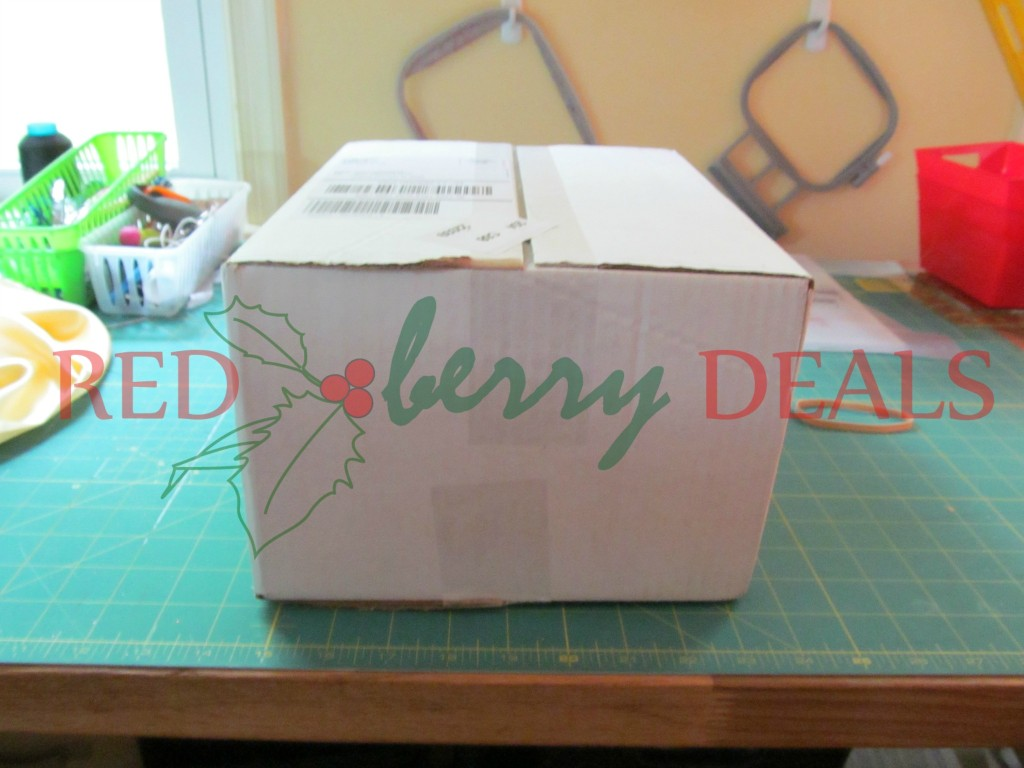If you were to imagine a story about the box, what could it be used for? Imagine this box as a vessel carrying a precious holiday gift from a family living in a small, snow-covered village to their loved ones across the country. It contains hand-crafted items, possibly those seen in the background, made with love and care. Understandably, the shipping label is filled out diligently to ensure every detail is correct. As it journeys through various weather conditions and transit depots, the box, marked with 'RED berry DEALS,' brings joy to its recipients who eagerly open it to find thoughtfully created surprises. That sounds wonderful. Could you tell more about the items in the box and their origins? Absolutely! Inside the box are handmade crafts reflecting the time and effort put into them by the family. One item is a set of knitted scarves and hats, meticulously crafted by an elderly grandmother who lives in that small village. With every knit and purl, she thought of the warmth it would provide. Another item is a batch of homemade berry preserves, each jar labeled with love — concoctions made from berries picked from the family's garden. Additionally, there’s an intricately designed photo frame made by the father, who used reclaimed wood from their ancestral home. Each piece tells a story of familial bonds, memories, and the joy of giving. Those crafts sound enchanting. How do the recipients react upon receiving them? When the recipients finally receive the box, their faces light up with joy and nostalgia. As they unwrap each item, they can't help but feel the connection and love imbued within. The knitted scarves and hats immediately bring warmth, not just physically, but emotionally. The berry preserves evoke memories of summer visits to the grandparents' garden. The photo frame finds a special place on the mantle, holding a cherished family photo. This thoughtful box becomes a symbol of love, care, and the unbroken bond of family, treasured for years to come. 